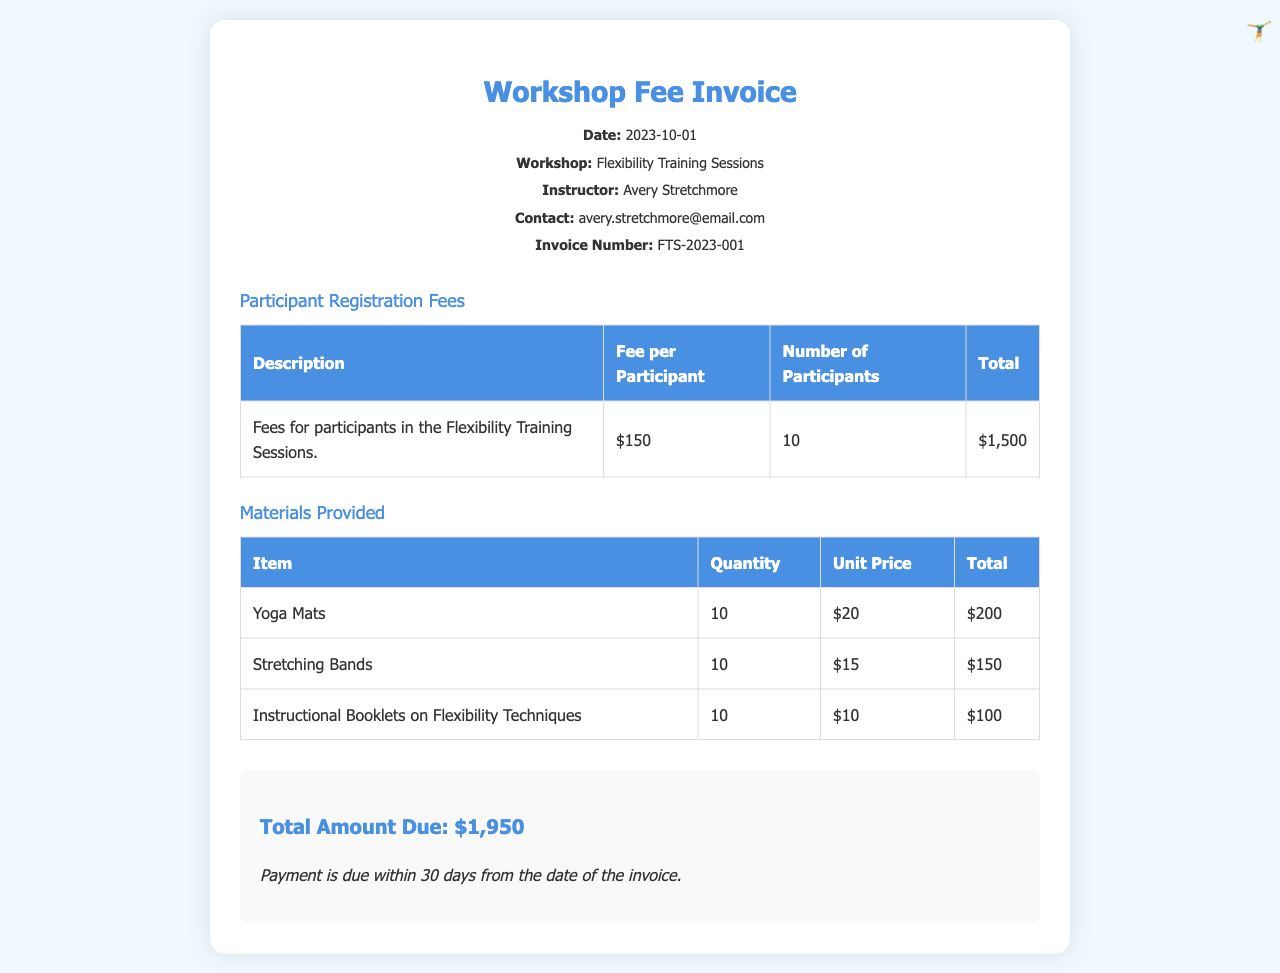what is the date of the invoice? The date of the invoice is stated in the header section of the document.
Answer: 2023-10-01 who is the instructor for the workshop? The instructor's name is mentioned in the header, providing identification for the workshop leader.
Answer: Avery Stretchmore how much is the fee per participant? The fee per participant is listed in the table of participant registration fees.
Answer: $150 what is the total number of participants? The total number of participants is found in the same table concerning registration fees.
Answer: 10 what is the total amount due? The total amount due is provided in the summary section at the bottom of the document.
Answer: $1,950 how many yoga mats were provided? The quantity of yoga mats is specified in the materials provided table.
Answer: 10 what is the unit price for stretching bands? The unit price for stretching bands is indicated in the materials provided table.
Answer: $15 what is the quantity of instructional booklets provided? The quantity of instructional booklets is detailed in the table titled materials provided.
Answer: 10 when is the payment due? The payment terms are noted in the summary section, reflecting the timeline for payment obligations.
Answer: within 30 days from the date of the invoice 